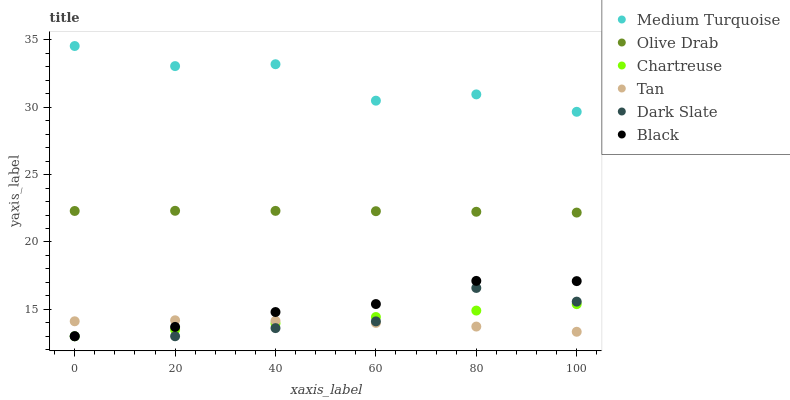Does Tan have the minimum area under the curve?
Answer yes or no. Yes. Does Medium Turquoise have the maximum area under the curve?
Answer yes or no. Yes. Does Chartreuse have the minimum area under the curve?
Answer yes or no. No. Does Chartreuse have the maximum area under the curve?
Answer yes or no. No. Is Chartreuse the smoothest?
Answer yes or no. Yes. Is Medium Turquoise the roughest?
Answer yes or no. Yes. Is Black the smoothest?
Answer yes or no. No. Is Black the roughest?
Answer yes or no. No. Does Dark Slate have the lowest value?
Answer yes or no. Yes. Does Medium Turquoise have the lowest value?
Answer yes or no. No. Does Medium Turquoise have the highest value?
Answer yes or no. Yes. Does Chartreuse have the highest value?
Answer yes or no. No. Is Black less than Medium Turquoise?
Answer yes or no. Yes. Is Medium Turquoise greater than Chartreuse?
Answer yes or no. Yes. Does Chartreuse intersect Black?
Answer yes or no. Yes. Is Chartreuse less than Black?
Answer yes or no. No. Is Chartreuse greater than Black?
Answer yes or no. No. Does Black intersect Medium Turquoise?
Answer yes or no. No. 